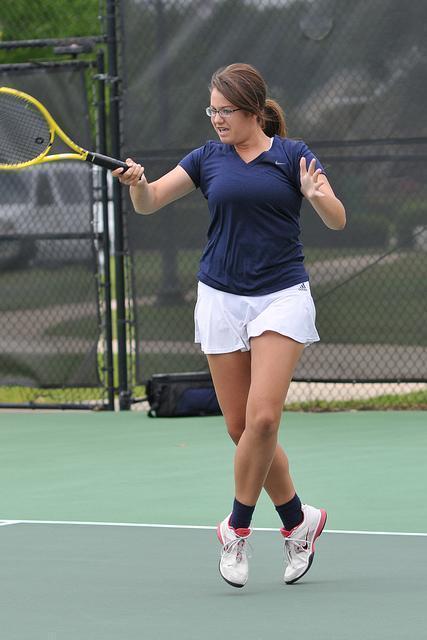How many cats are in the picture?
Give a very brief answer. 0. 